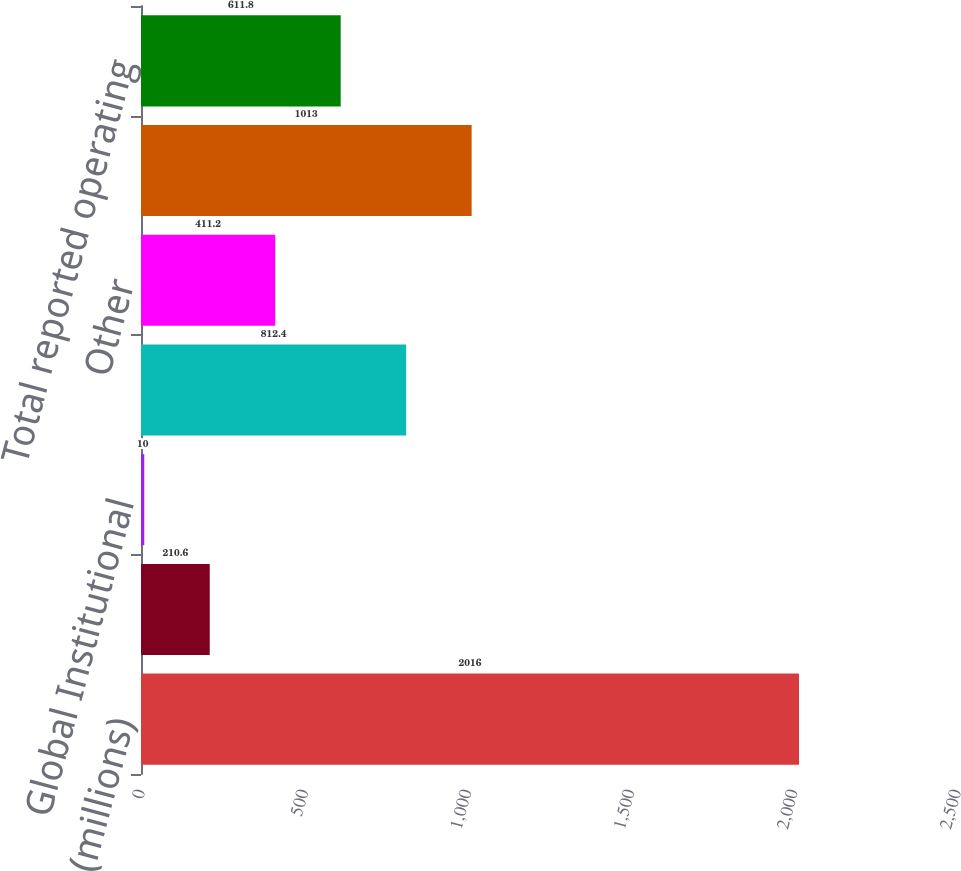<chart> <loc_0><loc_0><loc_500><loc_500><bar_chart><fcel>(millions)<fcel>Global Industrial<fcel>Global Institutional<fcel>Global Energy<fcel>Other<fcel>Subtotal at fixed currency<fcel>Total reported operating<nl><fcel>2016<fcel>210.6<fcel>10<fcel>812.4<fcel>411.2<fcel>1013<fcel>611.8<nl></chart> 